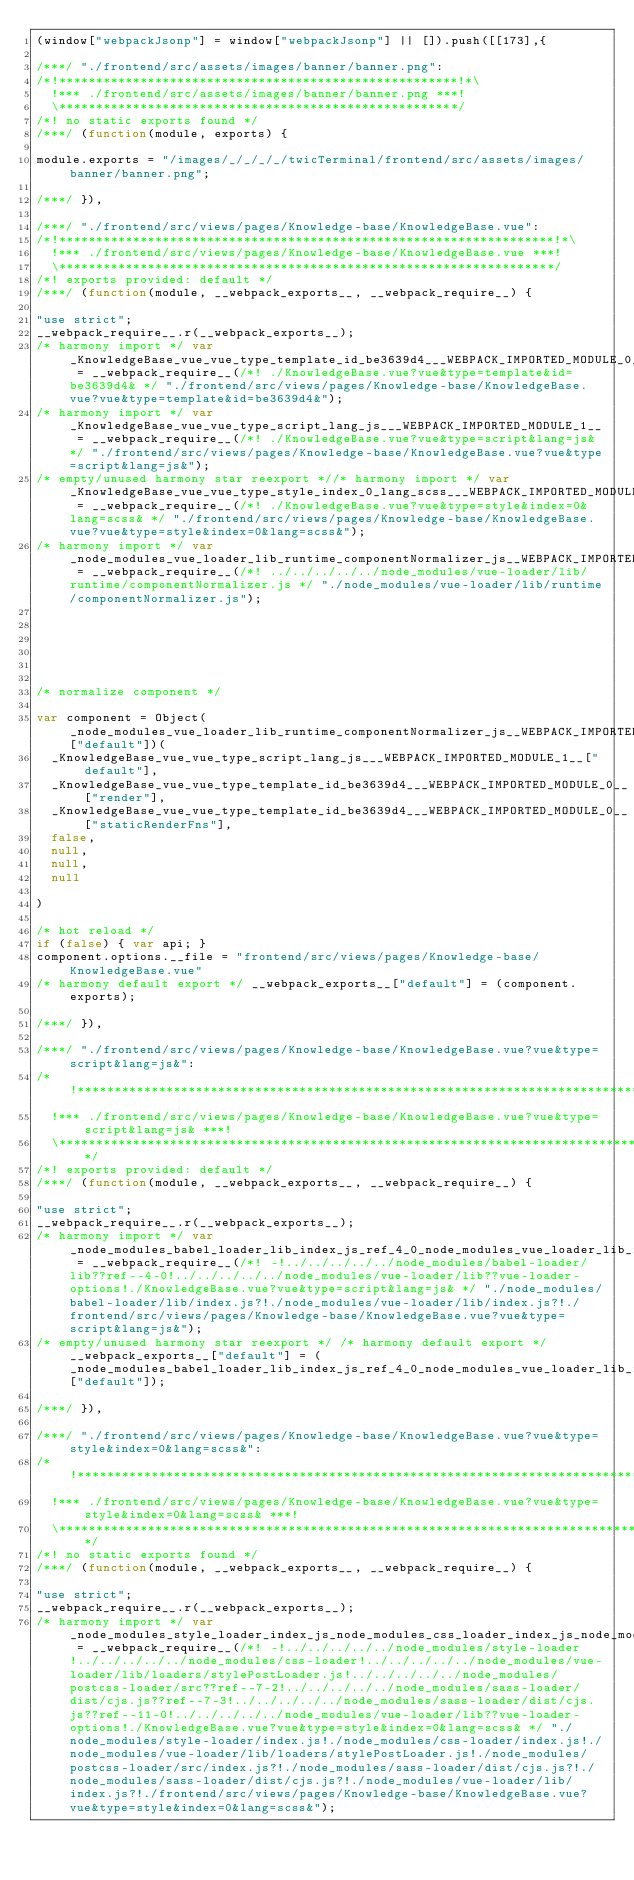Convert code to text. <code><loc_0><loc_0><loc_500><loc_500><_JavaScript_>(window["webpackJsonp"] = window["webpackJsonp"] || []).push([[173],{

/***/ "./frontend/src/assets/images/banner/banner.png":
/*!******************************************************!*\
  !*** ./frontend/src/assets/images/banner/banner.png ***!
  \******************************************************/
/*! no static exports found */
/***/ (function(module, exports) {

module.exports = "/images/_/_/_/_/twicTerminal/frontend/src/assets/images/banner/banner.png";

/***/ }),

/***/ "./frontend/src/views/pages/Knowledge-base/KnowledgeBase.vue":
/*!*******************************************************************!*\
  !*** ./frontend/src/views/pages/Knowledge-base/KnowledgeBase.vue ***!
  \*******************************************************************/
/*! exports provided: default */
/***/ (function(module, __webpack_exports__, __webpack_require__) {

"use strict";
__webpack_require__.r(__webpack_exports__);
/* harmony import */ var _KnowledgeBase_vue_vue_type_template_id_be3639d4___WEBPACK_IMPORTED_MODULE_0__ = __webpack_require__(/*! ./KnowledgeBase.vue?vue&type=template&id=be3639d4& */ "./frontend/src/views/pages/Knowledge-base/KnowledgeBase.vue?vue&type=template&id=be3639d4&");
/* harmony import */ var _KnowledgeBase_vue_vue_type_script_lang_js___WEBPACK_IMPORTED_MODULE_1__ = __webpack_require__(/*! ./KnowledgeBase.vue?vue&type=script&lang=js& */ "./frontend/src/views/pages/Knowledge-base/KnowledgeBase.vue?vue&type=script&lang=js&");
/* empty/unused harmony star reexport *//* harmony import */ var _KnowledgeBase_vue_vue_type_style_index_0_lang_scss___WEBPACK_IMPORTED_MODULE_2__ = __webpack_require__(/*! ./KnowledgeBase.vue?vue&type=style&index=0&lang=scss& */ "./frontend/src/views/pages/Knowledge-base/KnowledgeBase.vue?vue&type=style&index=0&lang=scss&");
/* harmony import */ var _node_modules_vue_loader_lib_runtime_componentNormalizer_js__WEBPACK_IMPORTED_MODULE_3__ = __webpack_require__(/*! ../../../../../node_modules/vue-loader/lib/runtime/componentNormalizer.js */ "./node_modules/vue-loader/lib/runtime/componentNormalizer.js");






/* normalize component */

var component = Object(_node_modules_vue_loader_lib_runtime_componentNormalizer_js__WEBPACK_IMPORTED_MODULE_3__["default"])(
  _KnowledgeBase_vue_vue_type_script_lang_js___WEBPACK_IMPORTED_MODULE_1__["default"],
  _KnowledgeBase_vue_vue_type_template_id_be3639d4___WEBPACK_IMPORTED_MODULE_0__["render"],
  _KnowledgeBase_vue_vue_type_template_id_be3639d4___WEBPACK_IMPORTED_MODULE_0__["staticRenderFns"],
  false,
  null,
  null,
  null
  
)

/* hot reload */
if (false) { var api; }
component.options.__file = "frontend/src/views/pages/Knowledge-base/KnowledgeBase.vue"
/* harmony default export */ __webpack_exports__["default"] = (component.exports);

/***/ }),

/***/ "./frontend/src/views/pages/Knowledge-base/KnowledgeBase.vue?vue&type=script&lang=js&":
/*!********************************************************************************************!*\
  !*** ./frontend/src/views/pages/Knowledge-base/KnowledgeBase.vue?vue&type=script&lang=js& ***!
  \********************************************************************************************/
/*! exports provided: default */
/***/ (function(module, __webpack_exports__, __webpack_require__) {

"use strict";
__webpack_require__.r(__webpack_exports__);
/* harmony import */ var _node_modules_babel_loader_lib_index_js_ref_4_0_node_modules_vue_loader_lib_index_js_vue_loader_options_KnowledgeBase_vue_vue_type_script_lang_js___WEBPACK_IMPORTED_MODULE_0__ = __webpack_require__(/*! -!../../../../../node_modules/babel-loader/lib??ref--4-0!../../../../../node_modules/vue-loader/lib??vue-loader-options!./KnowledgeBase.vue?vue&type=script&lang=js& */ "./node_modules/babel-loader/lib/index.js?!./node_modules/vue-loader/lib/index.js?!./frontend/src/views/pages/Knowledge-base/KnowledgeBase.vue?vue&type=script&lang=js&");
/* empty/unused harmony star reexport */ /* harmony default export */ __webpack_exports__["default"] = (_node_modules_babel_loader_lib_index_js_ref_4_0_node_modules_vue_loader_lib_index_js_vue_loader_options_KnowledgeBase_vue_vue_type_script_lang_js___WEBPACK_IMPORTED_MODULE_0__["default"]); 

/***/ }),

/***/ "./frontend/src/views/pages/Knowledge-base/KnowledgeBase.vue?vue&type=style&index=0&lang=scss&":
/*!*****************************************************************************************************!*\
  !*** ./frontend/src/views/pages/Knowledge-base/KnowledgeBase.vue?vue&type=style&index=0&lang=scss& ***!
  \*****************************************************************************************************/
/*! no static exports found */
/***/ (function(module, __webpack_exports__, __webpack_require__) {

"use strict";
__webpack_require__.r(__webpack_exports__);
/* harmony import */ var _node_modules_style_loader_index_js_node_modules_css_loader_index_js_node_modules_vue_loader_lib_loaders_stylePostLoader_js_node_modules_postcss_loader_src_index_js_ref_7_2_node_modules_sass_loader_dist_cjs_js_ref_7_3_node_modules_sass_loader_dist_cjs_js_ref_11_0_node_modules_vue_loader_lib_index_js_vue_loader_options_KnowledgeBase_vue_vue_type_style_index_0_lang_scss___WEBPACK_IMPORTED_MODULE_0__ = __webpack_require__(/*! -!../../../../../node_modules/style-loader!../../../../../node_modules/css-loader!../../../../../node_modules/vue-loader/lib/loaders/stylePostLoader.js!../../../../../node_modules/postcss-loader/src??ref--7-2!../../../../../node_modules/sass-loader/dist/cjs.js??ref--7-3!../../../../../node_modules/sass-loader/dist/cjs.js??ref--11-0!../../../../../node_modules/vue-loader/lib??vue-loader-options!./KnowledgeBase.vue?vue&type=style&index=0&lang=scss& */ "./node_modules/style-loader/index.js!./node_modules/css-loader/index.js!./node_modules/vue-loader/lib/loaders/stylePostLoader.js!./node_modules/postcss-loader/src/index.js?!./node_modules/sass-loader/dist/cjs.js?!./node_modules/sass-loader/dist/cjs.js?!./node_modules/vue-loader/lib/index.js?!./frontend/src/views/pages/Knowledge-base/KnowledgeBase.vue?vue&type=style&index=0&lang=scss&");</code> 